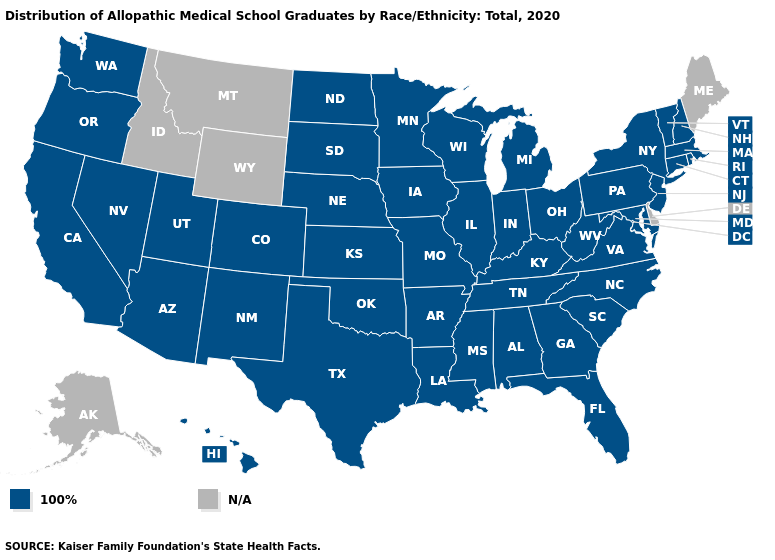What is the lowest value in states that border Pennsylvania?
Be succinct. 100%. Does the map have missing data?
Be succinct. Yes. What is the highest value in states that border Louisiana?
Short answer required. 100%. What is the highest value in the USA?
Concise answer only. 100%. Name the states that have a value in the range N/A?
Quick response, please. Alaska, Delaware, Idaho, Maine, Montana, Wyoming. How many symbols are there in the legend?
Quick response, please. 2. Name the states that have a value in the range 100%?
Concise answer only. Alabama, Arizona, Arkansas, California, Colorado, Connecticut, Florida, Georgia, Hawaii, Illinois, Indiana, Iowa, Kansas, Kentucky, Louisiana, Maryland, Massachusetts, Michigan, Minnesota, Mississippi, Missouri, Nebraska, Nevada, New Hampshire, New Jersey, New Mexico, New York, North Carolina, North Dakota, Ohio, Oklahoma, Oregon, Pennsylvania, Rhode Island, South Carolina, South Dakota, Tennessee, Texas, Utah, Vermont, Virginia, Washington, West Virginia, Wisconsin. Is the legend a continuous bar?
Concise answer only. No. Name the states that have a value in the range N/A?
Keep it brief. Alaska, Delaware, Idaho, Maine, Montana, Wyoming. What is the lowest value in states that border Nebraska?
Be succinct. 100%. How many symbols are there in the legend?
Be succinct. 2. 